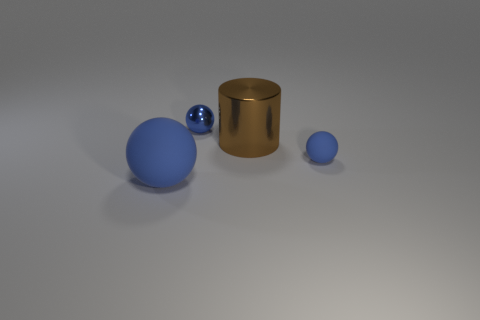Subtract all blue rubber balls. How many balls are left? 1 Subtract 1 spheres. How many spheres are left? 2 Add 3 blue matte balls. How many objects exist? 7 Subtract all cylinders. How many objects are left? 3 Subtract 0 blue cubes. How many objects are left? 4 Subtract all red things. Subtract all blue matte things. How many objects are left? 2 Add 2 large brown cylinders. How many large brown cylinders are left? 3 Add 1 large yellow matte balls. How many large yellow matte balls exist? 1 